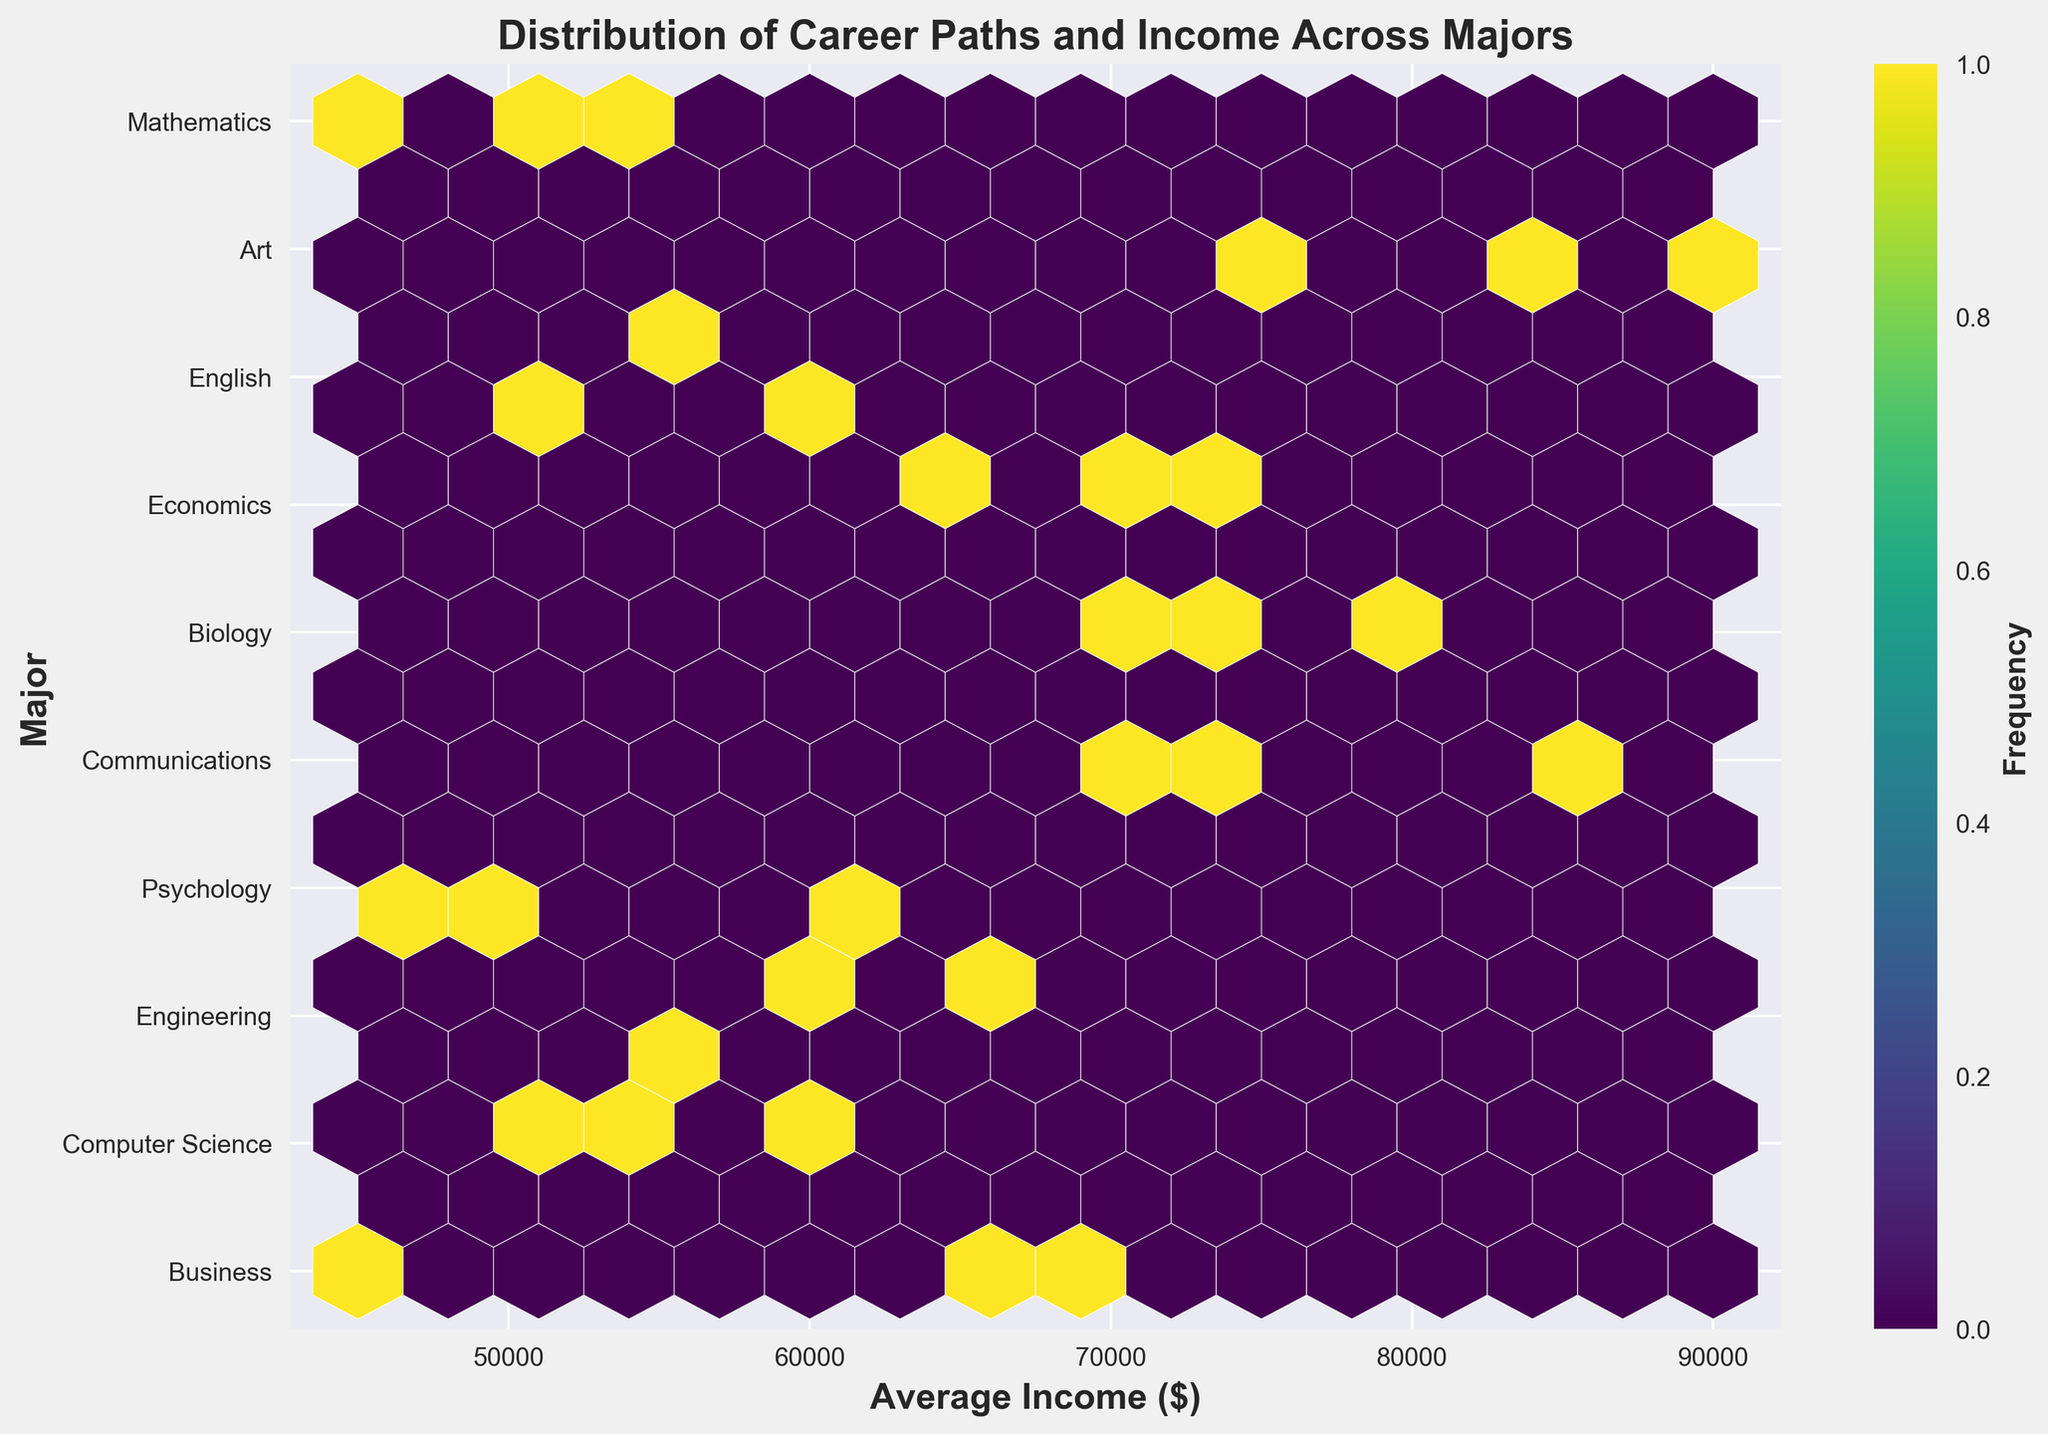What is the title of the plot? The title of the plot is usually located at the top center of the figure and provides a summary of what the plot represents.
Answer: Distribution of Career Paths and Income Across Majors What are the labels on the x and y axes? The x and y axis labels are typically placed along the horizontal and vertical axes, respectively. They describe what each axis represents.
Answer: x: Average Income ($), y: Major How many different majors are represented in the plot? The number of different majors can be determined by counting the unique labels along the y-axis.
Answer: 10 Which major appears to have the highest average income? To identify the major with the highest average income, look for the data point on the x-axis with the highest value and trace it to its corresponding y-axis label.
Answer: Mathematics What is the frequency of the most densely populated hexbin? The frequency can be identified by looking at the color of the most densely populated hexbin on the plot and matching it with the colorbar.
Answer: The answer will depend on the colorbar scale depicted Which major(s) have average income levels below $50,000? To find this, locate the x-axis value of $50,000 and identify which y-axis labels (majors) have data points to the left of this line.
Answer: Psychology, Communications, Art Which majors show careers with income levels higher than $80,000? Identify data points in the plot that are to the right of the $80,000 mark on the x-axis and trace them up to their y-axis labels.
Answer: Computer Science, Economics, Mathematics What is the median average income of all the career paths shown across all majors? To find the median, list all the average incomes, sort them, and identify the middle value.
Answer: Approximately $65000 Between business and engineering majors, which one has a more diverse range of average incomes? Examine the spread of data points for business and engineering majors along the x-axis. The major with a more spread out distribution of points indicates a more diverse range of average incomes.
Answer: Business 